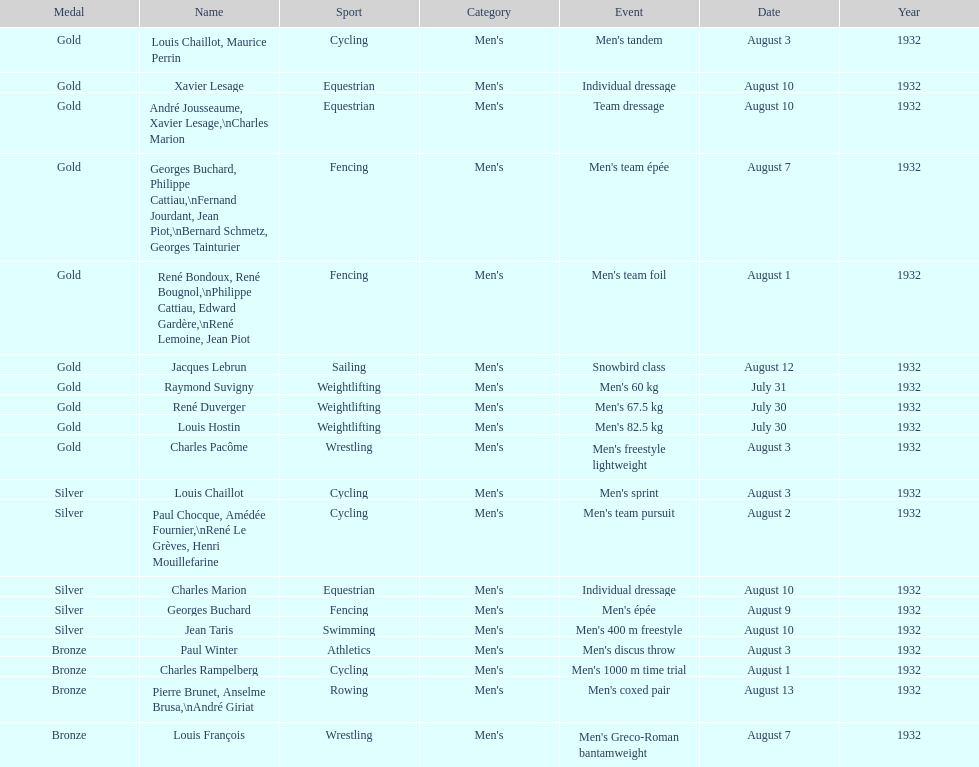What sport did louis challiot win the same medal as paul chocque in? Cycling. 